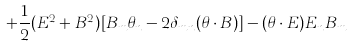Convert formula to latex. <formula><loc_0><loc_0><loc_500><loc_500>+ \frac { 1 } { 2 } ( E ^ { 2 } + B ^ { 2 } ) [ B _ { m } \theta _ { n } - 2 \delta _ { m n } ( \theta \cdot B ) ] - ( \theta \cdot E ) E _ { n } B _ { m }</formula> 